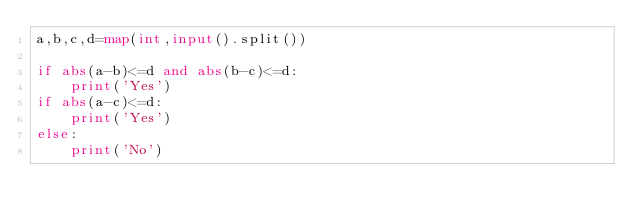<code> <loc_0><loc_0><loc_500><loc_500><_Python_>a,b,c,d=map(int,input().split())

if abs(a-b)<=d and abs(b-c)<=d:
    print('Yes')
if abs(a-c)<=d:
    print('Yes')
else:
    print('No')</code> 